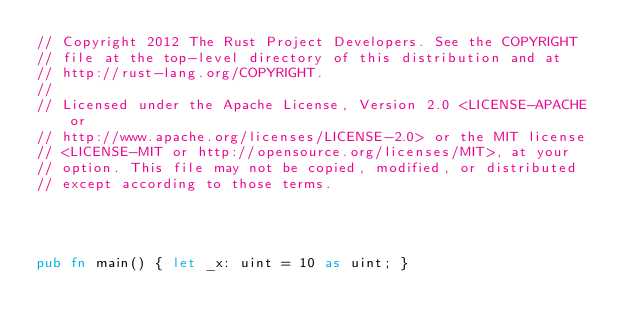<code> <loc_0><loc_0><loc_500><loc_500><_Rust_>// Copyright 2012 The Rust Project Developers. See the COPYRIGHT
// file at the top-level directory of this distribution and at
// http://rust-lang.org/COPYRIGHT.
//
// Licensed under the Apache License, Version 2.0 <LICENSE-APACHE or
// http://www.apache.org/licenses/LICENSE-2.0> or the MIT license
// <LICENSE-MIT or http://opensource.org/licenses/MIT>, at your
// option. This file may not be copied, modified, or distributed
// except according to those terms.




pub fn main() { let _x: uint = 10 as uint; }
</code> 